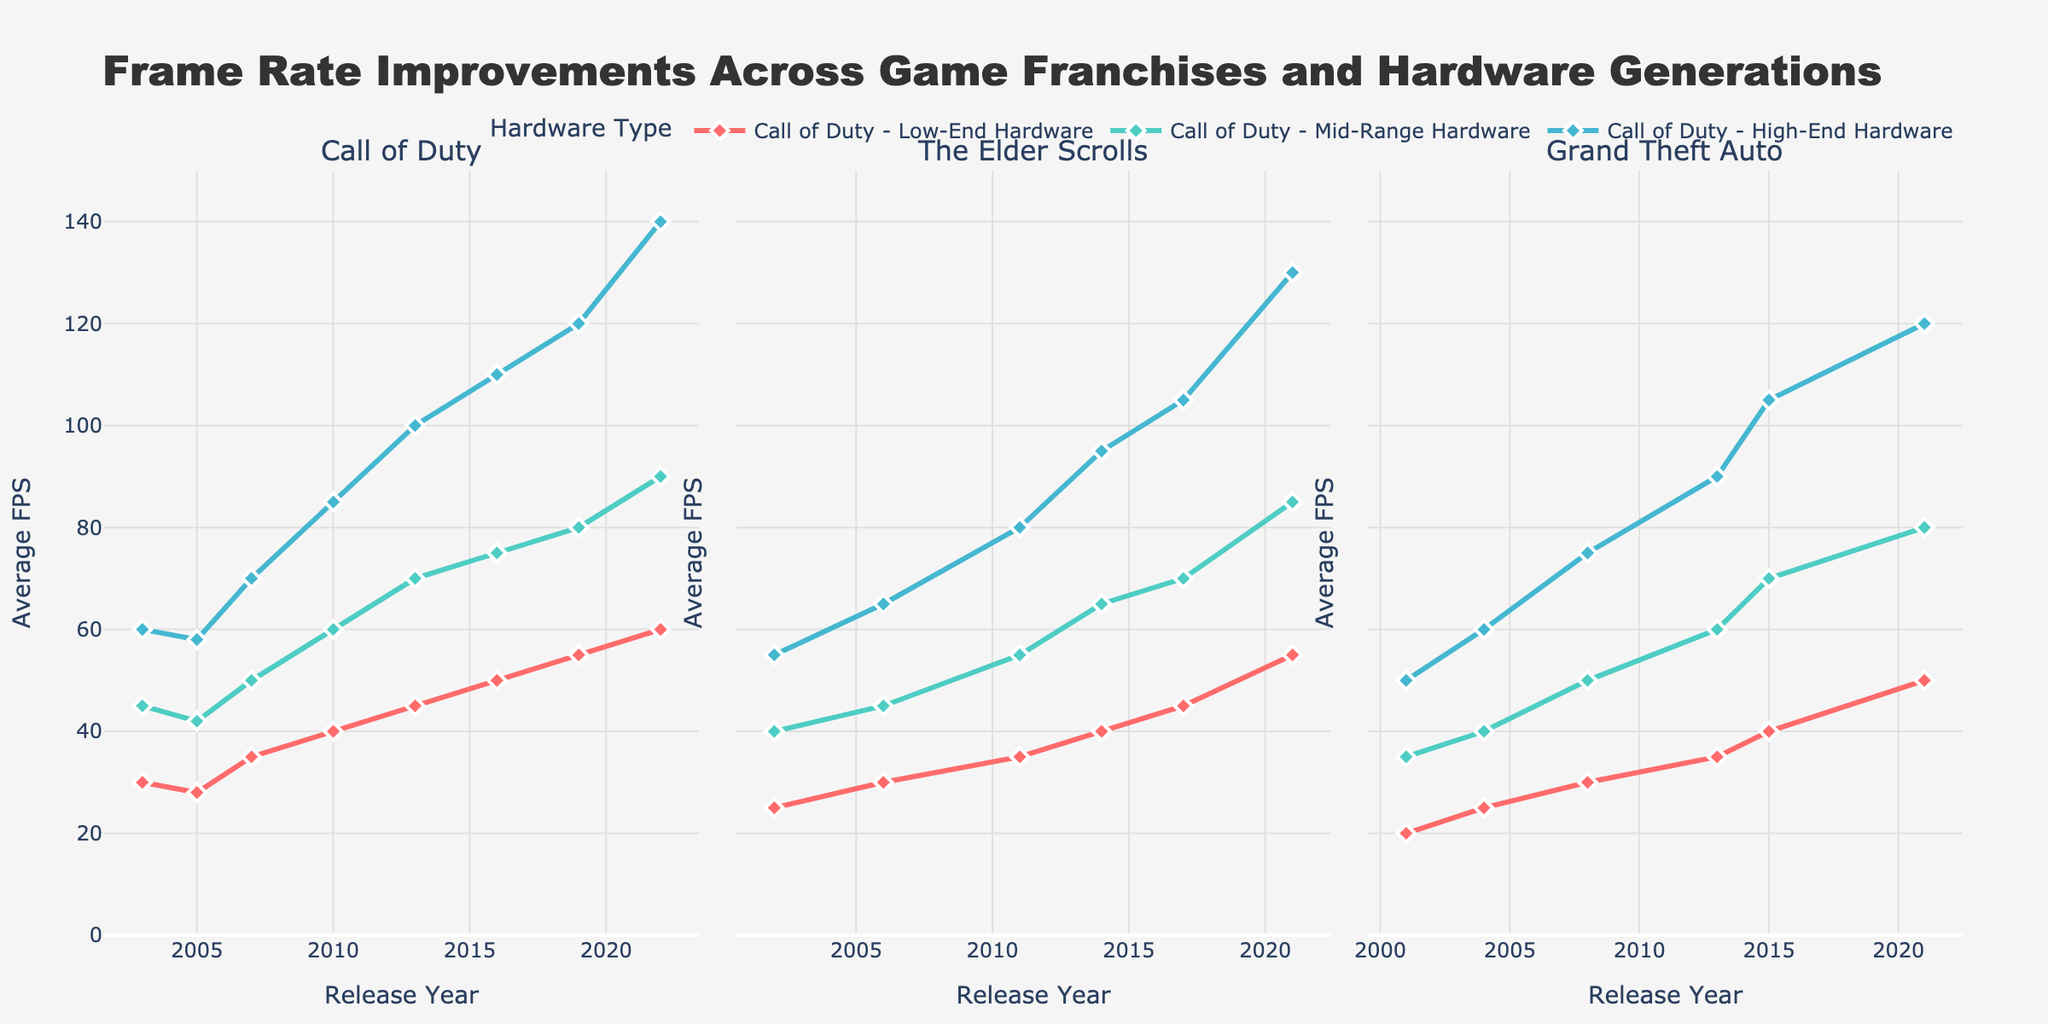Which game franchise shows the greatest increase in average FPS on low-end hardware from the earliest to the latest release? To solve this, we need to find the difference in average FPS between the latest and earliest release for each game franchise on low-end hardware:
- Call of Duty: 60 (2022) - 30 (2003) = 30 FPS
- The Elder Scrolls: 55 (2021) - 25 (2002) = 30 FPS
- Grand Theft Auto: 50 (2021) - 20 (2001) = 30 FPS. 
All three franchises show a 30 FPS increase.
Answer: Call of Duty, The Elder Scrolls, Grand Theft Auto Which game franchise shows the steepest increase in FPS for high-end hardware between any two consecutive releases? To solve this, look for the largest FPS jump in high-end hardware between two consecutive releases for each franchise:
- Call of Duty: 85 (2010) - 70 (2007) = 15 FPS (largest jump)
- The Elder Scrolls: 95 (2014) - 80 (2011) = 15 FPS (largest jump)
- Grand Theft Auto: 105 (2015) - 90 (2013) = 15 FPS (largest jump). 
This means all three franchises have a 15 FPS jump between two consecutive releases.
Answer: Call of Duty, The Elder Scrolls, Grand Theft Auto During which year did all three game franchises show an average FPS value of 50 in the low-end hardware category? To answer, observe the Average FPS (Low-End Hardware) line plots in each franchise subplot and find the common timeframe:
- Call of Duty (2019)
- The Elder Scrolls (no match)
- Grand Theft Auto (no match).
Only Call of Duty reached 50 FPS in 2019.
Answer: None Which hardware category shows the most significant improvement in FPS for Grand Theft Auto from 2001 to 2021? Calculate the difference in FPS for each hardware category from 2001 to 2021 for Grand Theft Auto:
- Low-End: 50 (2021) - 20 (2001) = 30 FPS
- Mid-Range: 80 (2021) - 35 (2001) = 45 FPS
- High-End: 120 (2021) - 50 (2001) = 70 FPS.
The high-end hardware shows the most significant improvement.
Answer: High-End Hardware By how much did the average FPS increase for The Elder Scrolls in the mid-range hardware category from its release in 2006 to 2017? Calculate the difference in FPS for mid-range hardware from 2006 to 2017 for The Elder Scrolls:
- 70 (2017) - 45 (2006) = 25 FPS.
Answer: 25 FPS Which game franchise consistently performed better in the high-end hardware category after 2010? Compare the Average FPS (High-End Hardware) values for 2011 and later:
- Call of Duty: 85 (2010), 100 (2013), 110 (2016), 120 (2019), 140 (2022)
- The Elder Scrolls: 80 (2011), 95 (2014), 105 (2017), 130 (2021)
- Grand Theft Auto: 75 (2008), 90 (2013), 105 (2015), 120 (2021). 
Call of Duty shows consistent performance improvement.
Answer: Call of Duty 